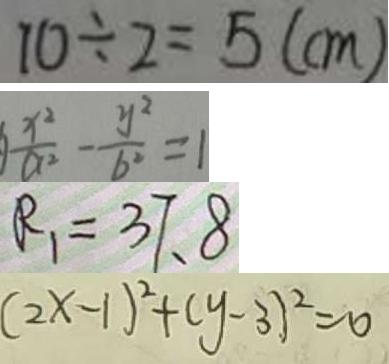Convert formula to latex. <formula><loc_0><loc_0><loc_500><loc_500>1 0 \div 2 = 5 ( c m ) 
 \frac { x ^ { 2 } } { a ^ { 2 } } - \frac { y ^ { 2 } } { b ^ { 2 } } = 1 
 R _ { 1 } = 3 7 . 8 
 ( 2 x - 1 ) ^ { 2 } + ( y - 3 ) ^ { 2 } = 0</formula> 